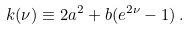<formula> <loc_0><loc_0><loc_500><loc_500>k ( \nu ) \equiv 2 a ^ { 2 } + b ( e ^ { 2 \nu } - 1 ) \, .</formula> 